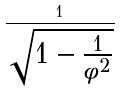<formula> <loc_0><loc_0><loc_500><loc_500>\frac { 1 } { \sqrt { 1 - \frac { 1 } { \phi ^ { 2 } } } }</formula> 